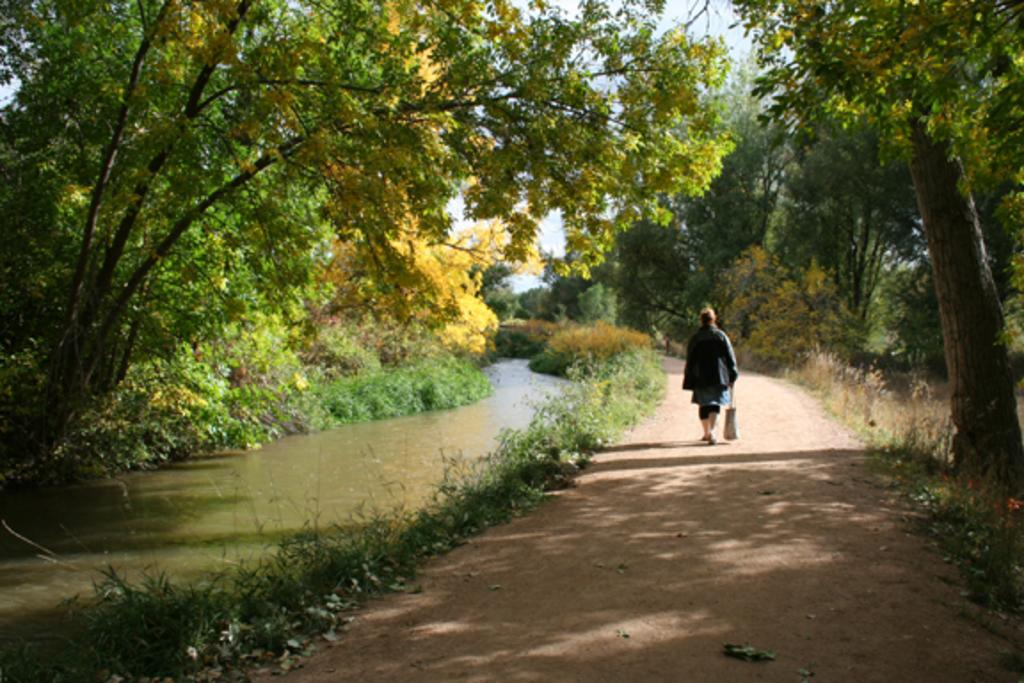Who or what is present in the image? There is a person in the image. What is the person doing in the image? The person is on the ground and holding a bag. What can be seen in the image besides the person? There are plants and water visible in the image. What is visible in the background of the image? There are trees and the sky visible in the background of the image. What type of curve can be seen in the person's order in the image? There is no order present in the image, and therefore no curve related to an order can be observed. 